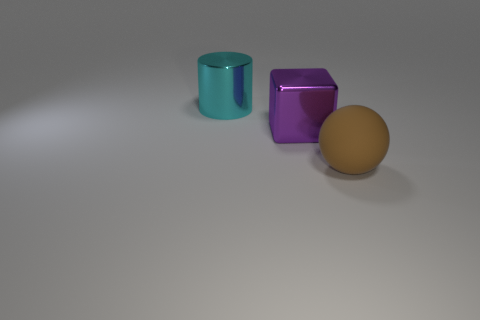There is a big metal thing in front of the cyan metallic cylinder; is it the same color as the big ball?
Make the answer very short. No. There is a large metallic object that is left of the large shiny thing that is in front of the cyan cylinder; what shape is it?
Provide a short and direct response. Cylinder. How many objects are either objects that are in front of the large purple metal cube or things to the left of the sphere?
Provide a short and direct response. 3. What is the shape of the large thing that is made of the same material as the purple cube?
Provide a succinct answer. Cylinder. Is there anything else of the same color as the big matte object?
Ensure brevity in your answer.  No. How many other things are there of the same size as the purple metallic cube?
Offer a very short reply. 2. What is the material of the sphere?
Your response must be concise. Rubber. Are there more shiny objects to the left of the purple metal block than gray balls?
Give a very brief answer. Yes. Is there a large red cylinder?
Make the answer very short. No. What number of other things are there of the same shape as the rubber thing?
Your answer should be compact. 0. 